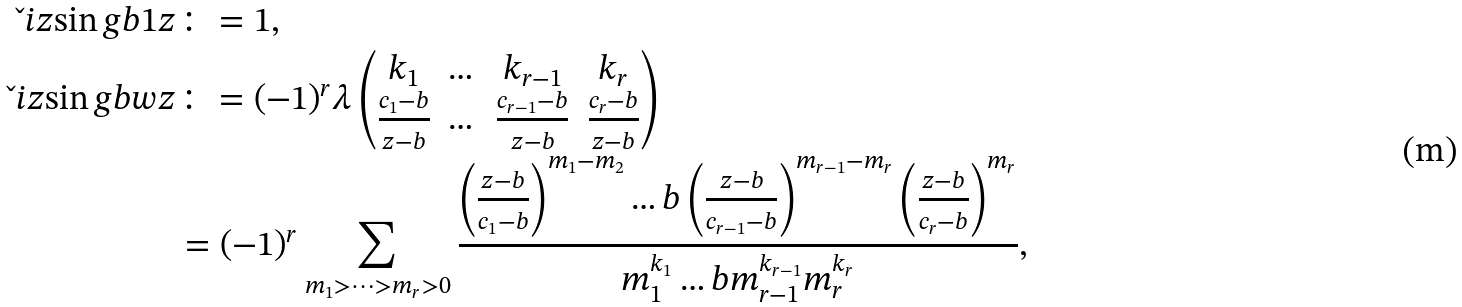<formula> <loc_0><loc_0><loc_500><loc_500>\L i z { \sin g } { b } { 1 } { z } & \colon = 1 , \\ \L i z { \sin g } { b } { w } { z } & \colon = ( - 1 ) ^ { r } \lambda \begin{pmatrix} k _ { 1 } & \dots & k _ { r - 1 } & k _ { r } \\ \frac { c _ { 1 } - b } { z - b } & \dots & \frac { c _ { r - 1 } - b } { z - b } & \frac { c _ { r } - b } { z - b } \end{pmatrix} \\ & = ( - 1 ) ^ { r } \sum _ { m _ { 1 } > \dots > m _ { r } > 0 } \frac { \left ( \frac { z - b } { c _ { 1 } - b } \right ) ^ { m _ { 1 } - m _ { 2 } } \dots b \left ( \frac { z - b } { c _ { r - 1 } - b } \right ) ^ { m _ { r - 1 } - m _ { r } } \left ( \frac { z - b } { c _ { r } - b } \right ) ^ { m _ { r } } } { m _ { 1 } ^ { k _ { 1 } } \dots b m _ { r - 1 } ^ { k _ { r - 1 } } m _ { r } ^ { k _ { r } } } ,</formula> 